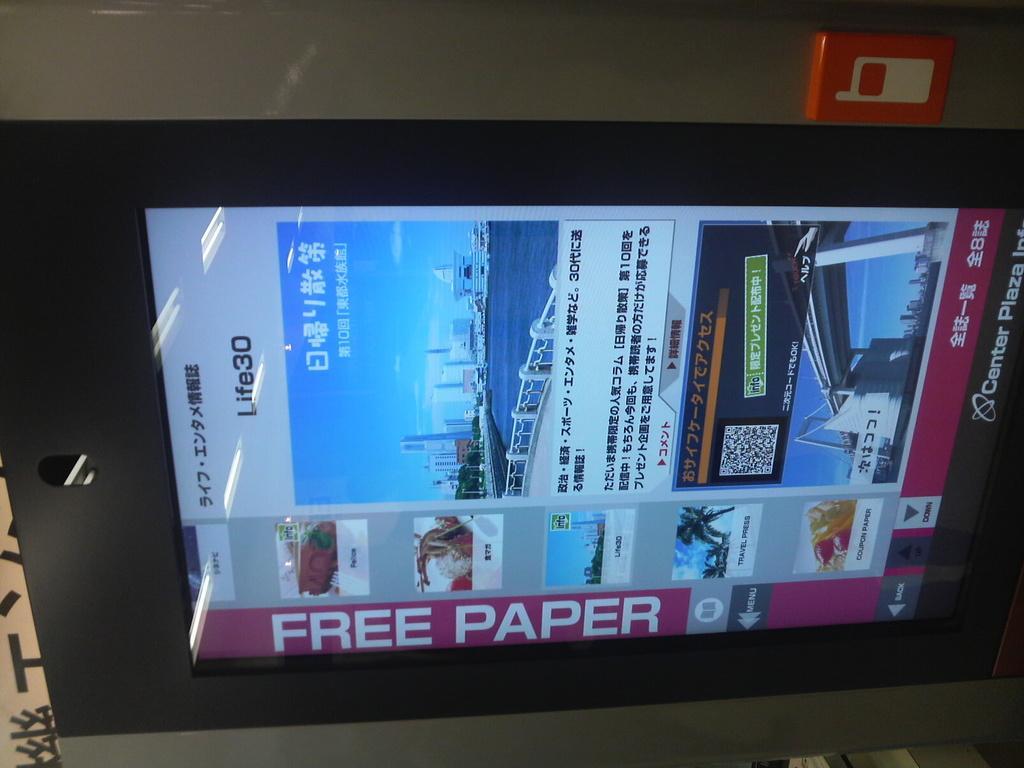Can you describe this image briefly? In this image in front there is a screen. Behind the screen there is a wall with some object on it. 